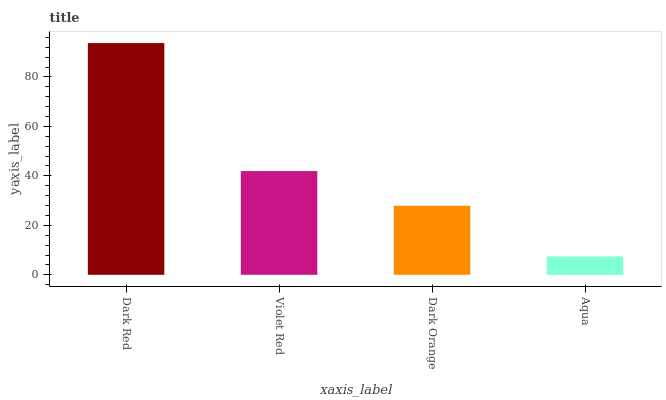Is Aqua the minimum?
Answer yes or no. Yes. Is Dark Red the maximum?
Answer yes or no. Yes. Is Violet Red the minimum?
Answer yes or no. No. Is Violet Red the maximum?
Answer yes or no. No. Is Dark Red greater than Violet Red?
Answer yes or no. Yes. Is Violet Red less than Dark Red?
Answer yes or no. Yes. Is Violet Red greater than Dark Red?
Answer yes or no. No. Is Dark Red less than Violet Red?
Answer yes or no. No. Is Violet Red the high median?
Answer yes or no. Yes. Is Dark Orange the low median?
Answer yes or no. Yes. Is Aqua the high median?
Answer yes or no. No. Is Violet Red the low median?
Answer yes or no. No. 